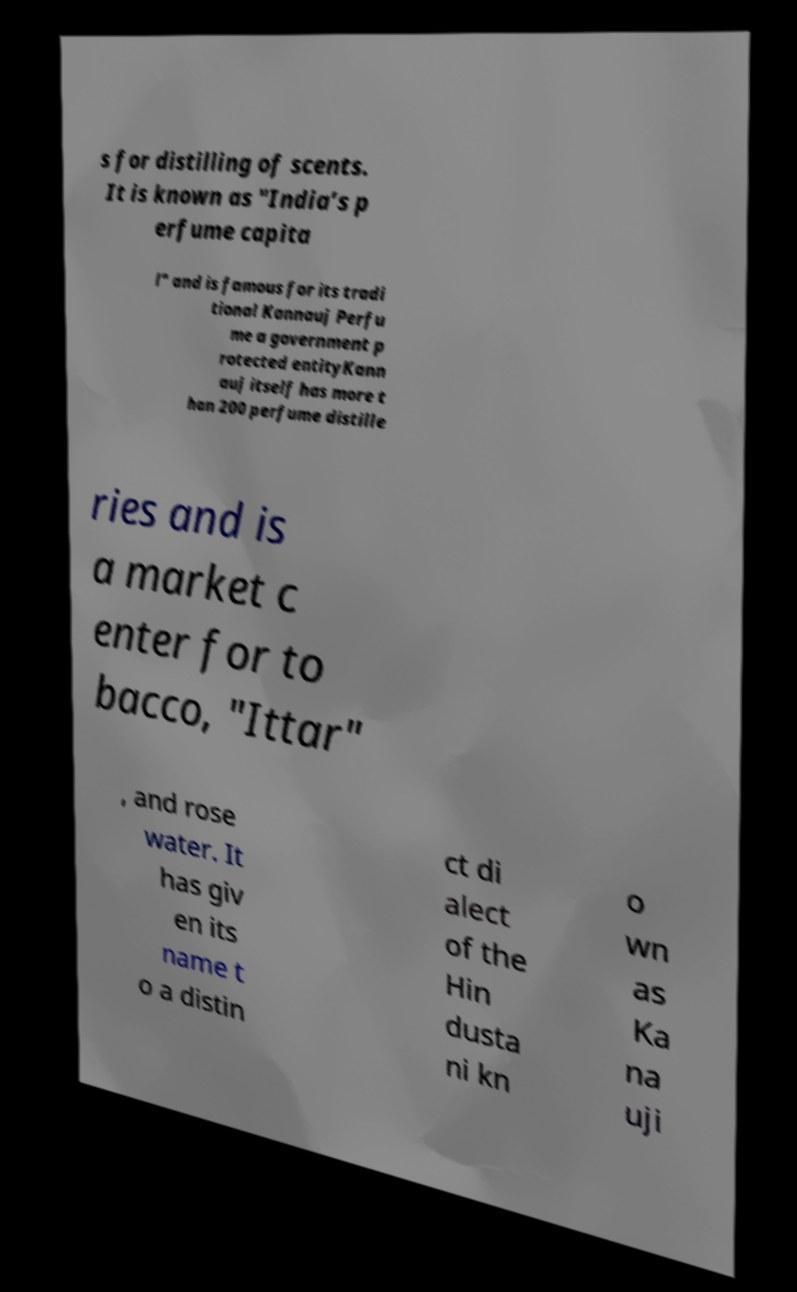Can you read and provide the text displayed in the image?This photo seems to have some interesting text. Can you extract and type it out for me? s for distilling of scents. It is known as "India’s p erfume capita l" and is famous for its tradi tional Kannauj Perfu me a government p rotected entityKann auj itself has more t han 200 perfume distille ries and is a market c enter for to bacco, "Ittar" , and rose water. It has giv en its name t o a distin ct di alect of the Hin dusta ni kn o wn as Ka na uji 